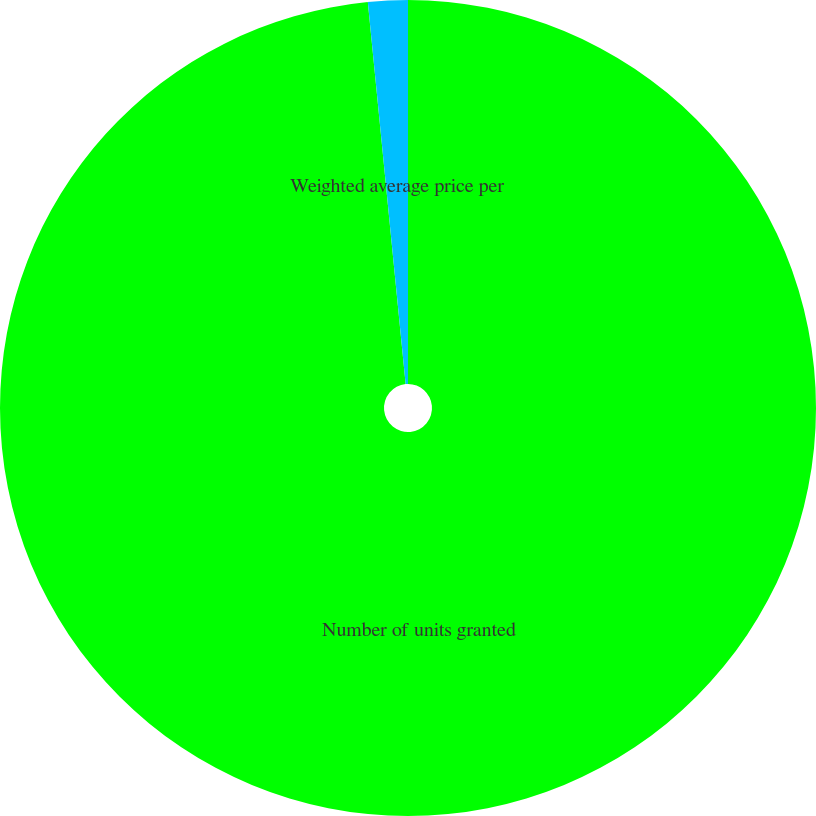<chart> <loc_0><loc_0><loc_500><loc_500><pie_chart><fcel>Number of units granted<fcel>Weighted average price per<nl><fcel>98.43%<fcel>1.57%<nl></chart> 